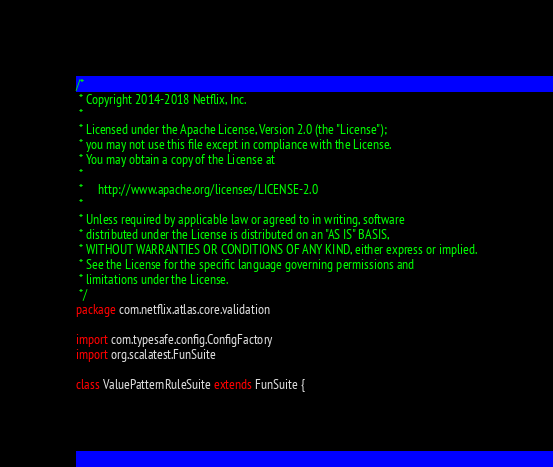Convert code to text. <code><loc_0><loc_0><loc_500><loc_500><_Scala_>/*
 * Copyright 2014-2018 Netflix, Inc.
 *
 * Licensed under the Apache License, Version 2.0 (the "License");
 * you may not use this file except in compliance with the License.
 * You may obtain a copy of the License at
 *
 *     http://www.apache.org/licenses/LICENSE-2.0
 *
 * Unless required by applicable law or agreed to in writing, software
 * distributed under the License is distributed on an "AS IS" BASIS,
 * WITHOUT WARRANTIES OR CONDITIONS OF ANY KIND, either express or implied.
 * See the License for the specific language governing permissions and
 * limitations under the License.
 */
package com.netflix.atlas.core.validation

import com.typesafe.config.ConfigFactory
import org.scalatest.FunSuite

class ValuePatternRuleSuite extends FunSuite {
</code> 